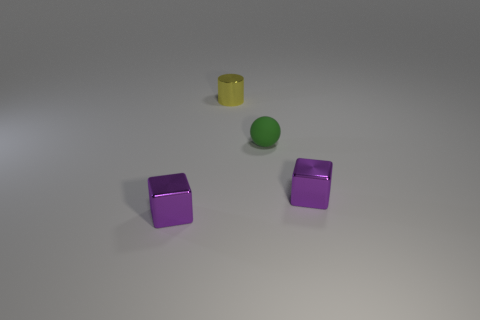Add 3 small green balls. How many objects exist? 7 Subtract all cylinders. How many objects are left? 3 Subtract all blocks. Subtract all green spheres. How many objects are left? 1 Add 1 tiny spheres. How many tiny spheres are left? 2 Add 4 tiny yellow matte balls. How many tiny yellow matte balls exist? 4 Subtract 0 blue balls. How many objects are left? 4 